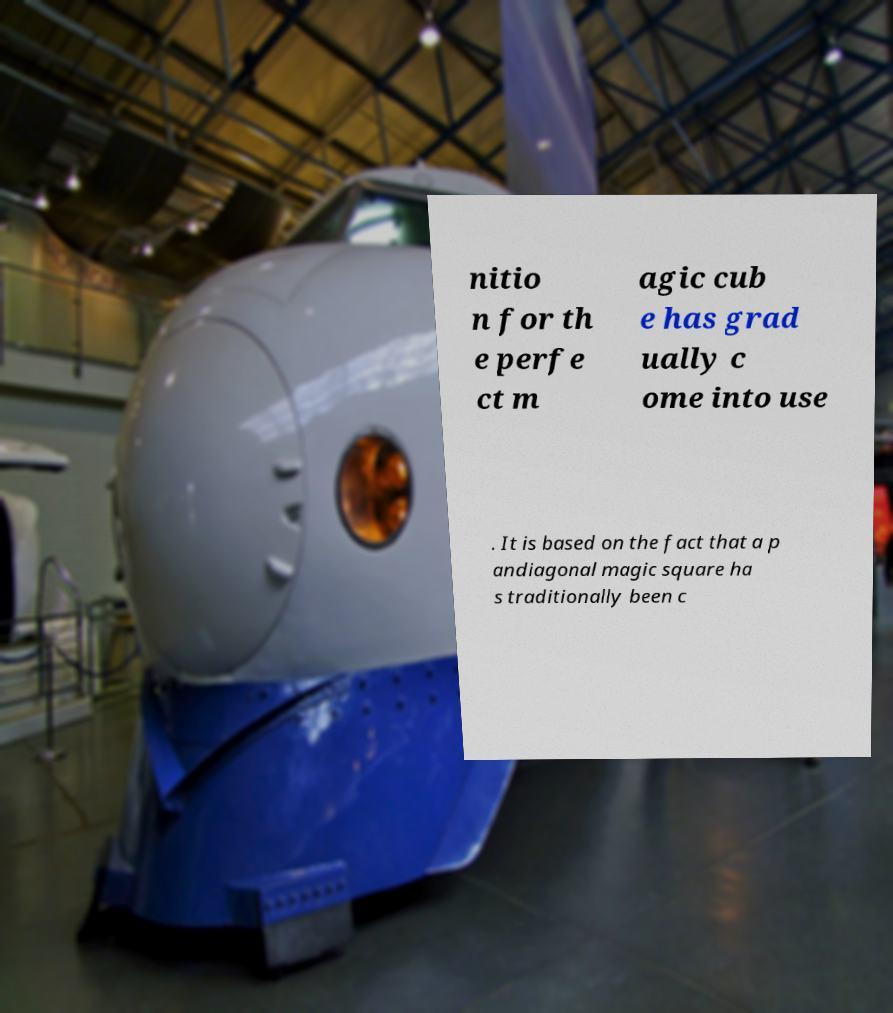I need the written content from this picture converted into text. Can you do that? nitio n for th e perfe ct m agic cub e has grad ually c ome into use . It is based on the fact that a p andiagonal magic square ha s traditionally been c 